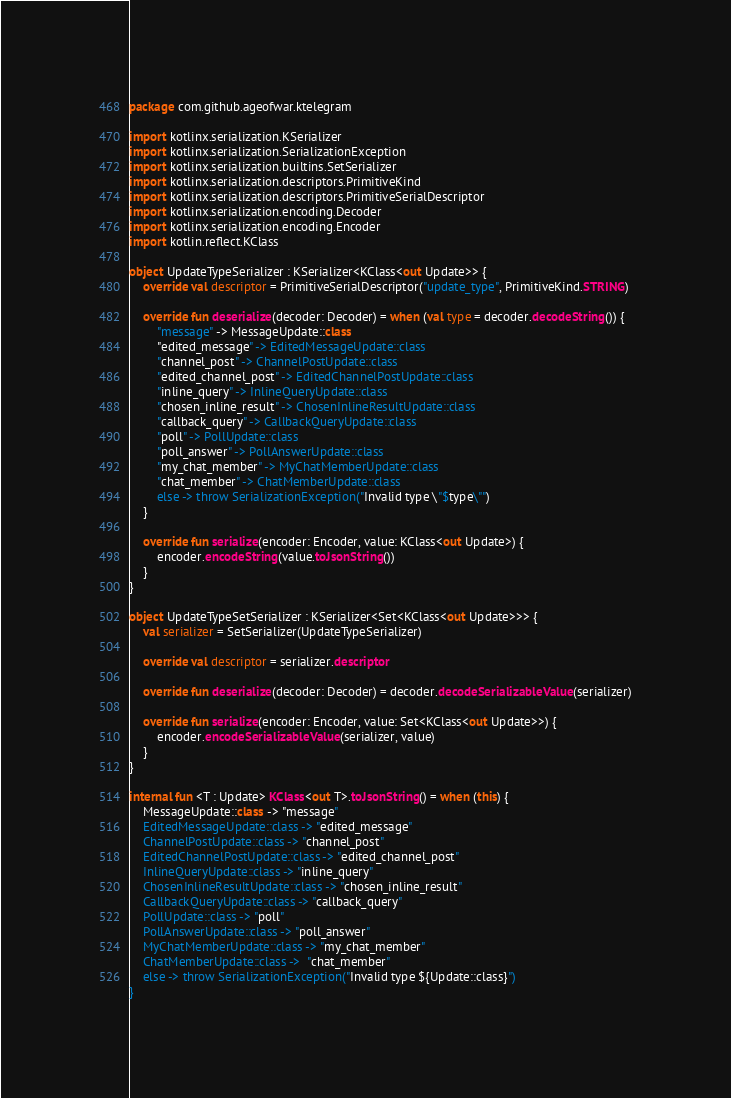<code> <loc_0><loc_0><loc_500><loc_500><_Kotlin_>package com.github.ageofwar.ktelegram

import kotlinx.serialization.KSerializer
import kotlinx.serialization.SerializationException
import kotlinx.serialization.builtins.SetSerializer
import kotlinx.serialization.descriptors.PrimitiveKind
import kotlinx.serialization.descriptors.PrimitiveSerialDescriptor
import kotlinx.serialization.encoding.Decoder
import kotlinx.serialization.encoding.Encoder
import kotlin.reflect.KClass

object UpdateTypeSerializer : KSerializer<KClass<out Update>> {
    override val descriptor = PrimitiveSerialDescriptor("update_type", PrimitiveKind.STRING)

    override fun deserialize(decoder: Decoder) = when (val type = decoder.decodeString()) {
        "message" -> MessageUpdate::class
        "edited_message" -> EditedMessageUpdate::class
        "channel_post" -> ChannelPostUpdate::class
        "edited_channel_post" -> EditedChannelPostUpdate::class
        "inline_query" -> InlineQueryUpdate::class
        "chosen_inline_result" -> ChosenInlineResultUpdate::class
        "callback_query" -> CallbackQueryUpdate::class
        "poll" -> PollUpdate::class
        "poll_answer" -> PollAnswerUpdate::class
        "my_chat_member" -> MyChatMemberUpdate::class
        "chat_member" -> ChatMemberUpdate::class
        else -> throw SerializationException("Invalid type \"$type\"")
    }

    override fun serialize(encoder: Encoder, value: KClass<out Update>) {
        encoder.encodeString(value.toJsonString())
    }
}

object UpdateTypeSetSerializer : KSerializer<Set<KClass<out Update>>> {
    val serializer = SetSerializer(UpdateTypeSerializer)

    override val descriptor = serializer.descriptor

    override fun deserialize(decoder: Decoder) = decoder.decodeSerializableValue(serializer)

    override fun serialize(encoder: Encoder, value: Set<KClass<out Update>>) {
        encoder.encodeSerializableValue(serializer, value)
    }
}

internal fun <T : Update> KClass<out T>.toJsonString() = when (this) {
    MessageUpdate::class -> "message"
    EditedMessageUpdate::class -> "edited_message"
    ChannelPostUpdate::class -> "channel_post"
    EditedChannelPostUpdate::class -> "edited_channel_post"
    InlineQueryUpdate::class -> "inline_query"
    ChosenInlineResultUpdate::class -> "chosen_inline_result"
    CallbackQueryUpdate::class -> "callback_query"
    PollUpdate::class -> "poll"
    PollAnswerUpdate::class -> "poll_answer"
    MyChatMemberUpdate::class -> "my_chat_member"
    ChatMemberUpdate::class ->  "chat_member"
    else -> throw SerializationException("Invalid type ${Update::class}")
}
</code> 